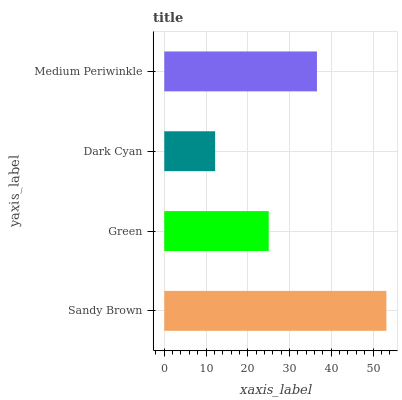Is Dark Cyan the minimum?
Answer yes or no. Yes. Is Sandy Brown the maximum?
Answer yes or no. Yes. Is Green the minimum?
Answer yes or no. No. Is Green the maximum?
Answer yes or no. No. Is Sandy Brown greater than Green?
Answer yes or no. Yes. Is Green less than Sandy Brown?
Answer yes or no. Yes. Is Green greater than Sandy Brown?
Answer yes or no. No. Is Sandy Brown less than Green?
Answer yes or no. No. Is Medium Periwinkle the high median?
Answer yes or no. Yes. Is Green the low median?
Answer yes or no. Yes. Is Sandy Brown the high median?
Answer yes or no. No. Is Dark Cyan the low median?
Answer yes or no. No. 